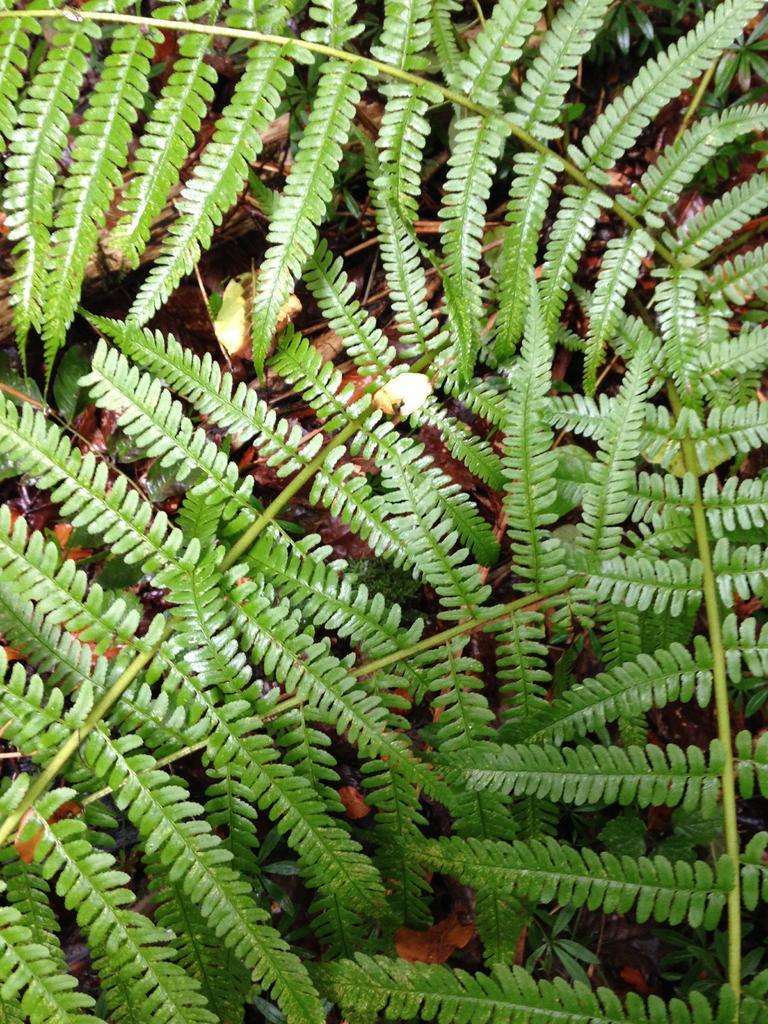Could you give a brief overview of what you see in this image? In this image I can see there are plants. 